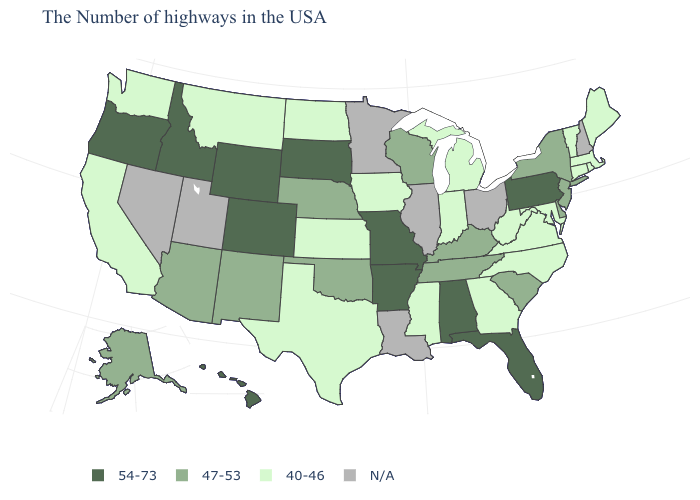What is the value of New York?
Be succinct. 47-53. Name the states that have a value in the range N/A?
Write a very short answer. New Hampshire, Ohio, Illinois, Louisiana, Minnesota, Utah, Nevada. Which states have the lowest value in the USA?
Answer briefly. Maine, Massachusetts, Rhode Island, Vermont, Connecticut, Maryland, Virginia, North Carolina, West Virginia, Georgia, Michigan, Indiana, Mississippi, Iowa, Kansas, Texas, North Dakota, Montana, California, Washington. Does the first symbol in the legend represent the smallest category?
Keep it brief. No. What is the value of West Virginia?
Write a very short answer. 40-46. Does New Jersey have the highest value in the USA?
Short answer required. No. What is the highest value in the USA?
Give a very brief answer. 54-73. Which states hav the highest value in the West?
Quick response, please. Wyoming, Colorado, Idaho, Oregon, Hawaii. What is the value of Rhode Island?
Keep it brief. 40-46. Name the states that have a value in the range 47-53?
Concise answer only. New York, New Jersey, Delaware, South Carolina, Kentucky, Tennessee, Wisconsin, Nebraska, Oklahoma, New Mexico, Arizona, Alaska. Does the first symbol in the legend represent the smallest category?
Concise answer only. No. Does Hawaii have the highest value in the USA?
Be succinct. Yes. Name the states that have a value in the range 47-53?
Answer briefly. New York, New Jersey, Delaware, South Carolina, Kentucky, Tennessee, Wisconsin, Nebraska, Oklahoma, New Mexico, Arizona, Alaska. What is the highest value in the USA?
Answer briefly. 54-73. 